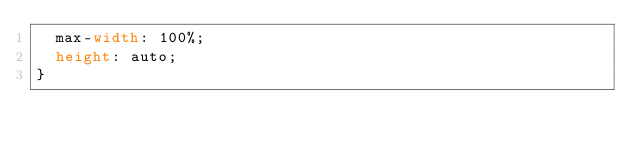Convert code to text. <code><loc_0><loc_0><loc_500><loc_500><_CSS_>  max-width: 100%;
  height: auto;
}</code> 